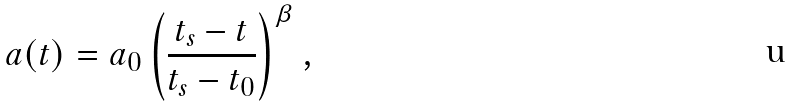Convert formula to latex. <formula><loc_0><loc_0><loc_500><loc_500>a ( t ) = a _ { 0 } \left ( \frac { t _ { s } - t } { t _ { s } - t _ { 0 } } \right ) ^ { \beta } ,</formula> 